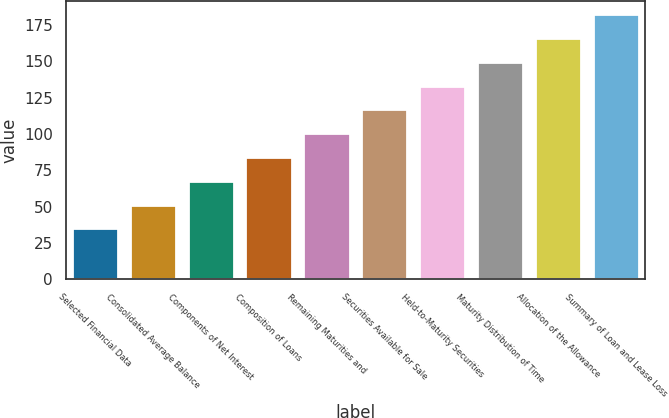<chart> <loc_0><loc_0><loc_500><loc_500><bar_chart><fcel>Selected Financial Data<fcel>Consolidated Average Balance<fcel>Components of Net Interest<fcel>Composition of Loans<fcel>Remaining Maturities and<fcel>Securities Available for Sale<fcel>Held-to-Maturity Securities<fcel>Maturity Distribution of Time<fcel>Allocation of the Allowance<fcel>Summary of Loan and Lease Loss<nl><fcel>35<fcel>51.4<fcel>67.8<fcel>84.2<fcel>100.6<fcel>117<fcel>133.4<fcel>149.8<fcel>166.2<fcel>182.6<nl></chart> 